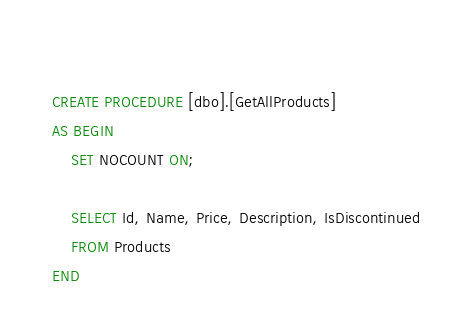<code> <loc_0><loc_0><loc_500><loc_500><_SQL_>  
CREATE PROCEDURE [dbo].[GetAllProducts]	
AS BEGIN
    SET NOCOUNT ON;

    SELECT Id, Name, Price, Description, IsDiscontinued
    FROM Products
END
</code> 